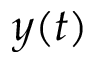<formula> <loc_0><loc_0><loc_500><loc_500>y ( t )</formula> 